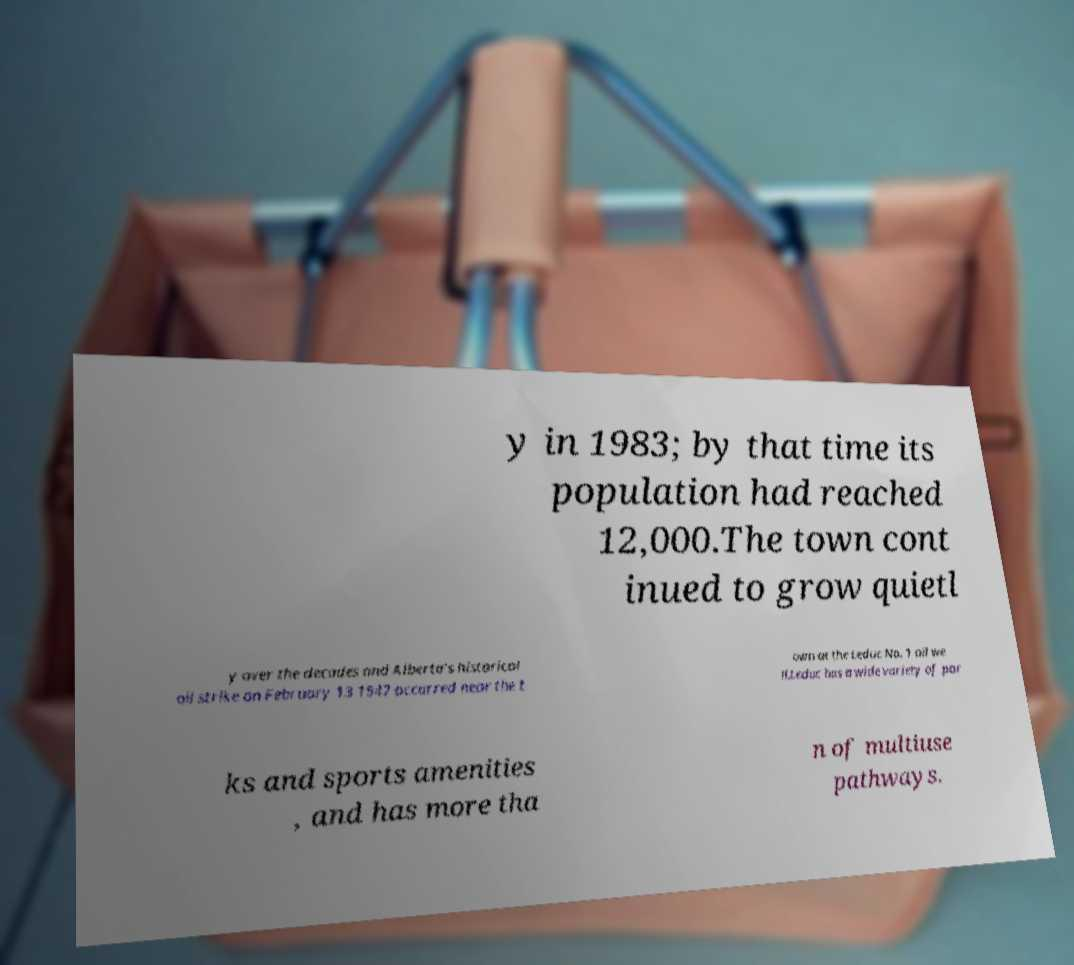Could you assist in decoding the text presented in this image and type it out clearly? y in 1983; by that time its population had reached 12,000.The town cont inued to grow quietl y over the decades and Alberta's historical oil strike on February 13 1947 occurred near the t own at the Leduc No. 1 oil we ll.Leduc has a wide variety of par ks and sports amenities , and has more tha n of multiuse pathways. 